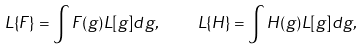<formula> <loc_0><loc_0><loc_500><loc_500>L \{ F \} = \int F ( g ) L [ g ] d g , \quad L \{ H \} = \int H ( g ) L [ g ] d g ,</formula> 